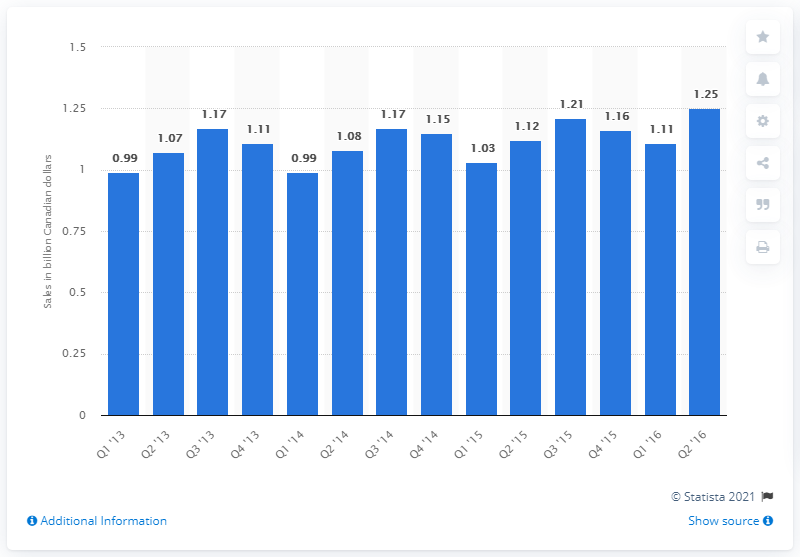Specify some key components in this picture. The sales of household cleaning supplies, chemicals, and paper products in the first quarter of 2013 were 0.99. 